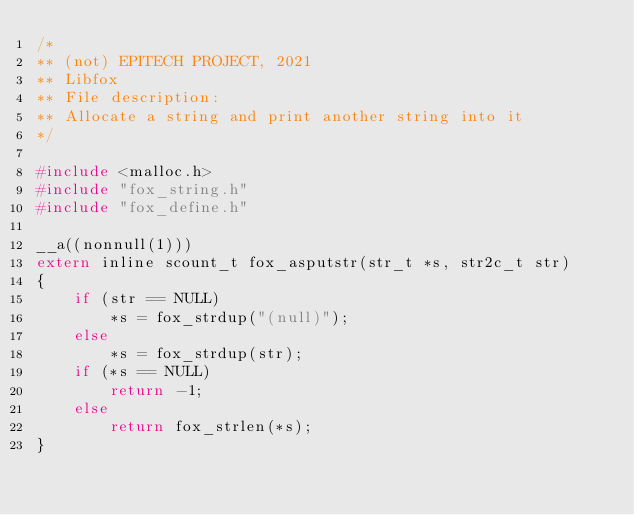<code> <loc_0><loc_0><loc_500><loc_500><_C_>/*
** (not) EPITECH PROJECT, 2021
** Libfox
** File description:
** Allocate a string and print another string into it
*/

#include <malloc.h>
#include "fox_string.h"
#include "fox_define.h"

__a((nonnull(1)))
extern inline scount_t fox_asputstr(str_t *s, str2c_t str)
{
    if (str == NULL)
        *s = fox_strdup("(null)");
    else
        *s = fox_strdup(str);
    if (*s == NULL)
        return -1;
    else
        return fox_strlen(*s);
}
</code> 